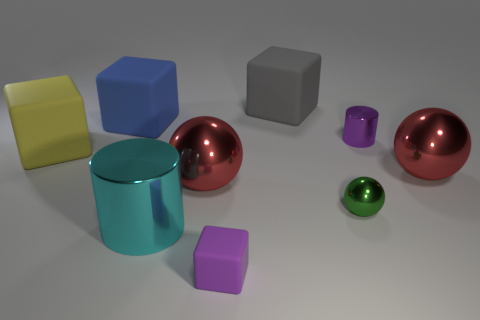Subtract all gray matte cubes. How many cubes are left? 3 Subtract all brown cubes. Subtract all green balls. How many cubes are left? 4 Add 1 small purple objects. How many objects exist? 10 Subtract all blocks. How many objects are left? 5 Subtract all large blue things. Subtract all spheres. How many objects are left? 5 Add 2 tiny purple cubes. How many tiny purple cubes are left? 3 Add 2 metallic balls. How many metallic balls exist? 5 Subtract 1 gray cubes. How many objects are left? 8 